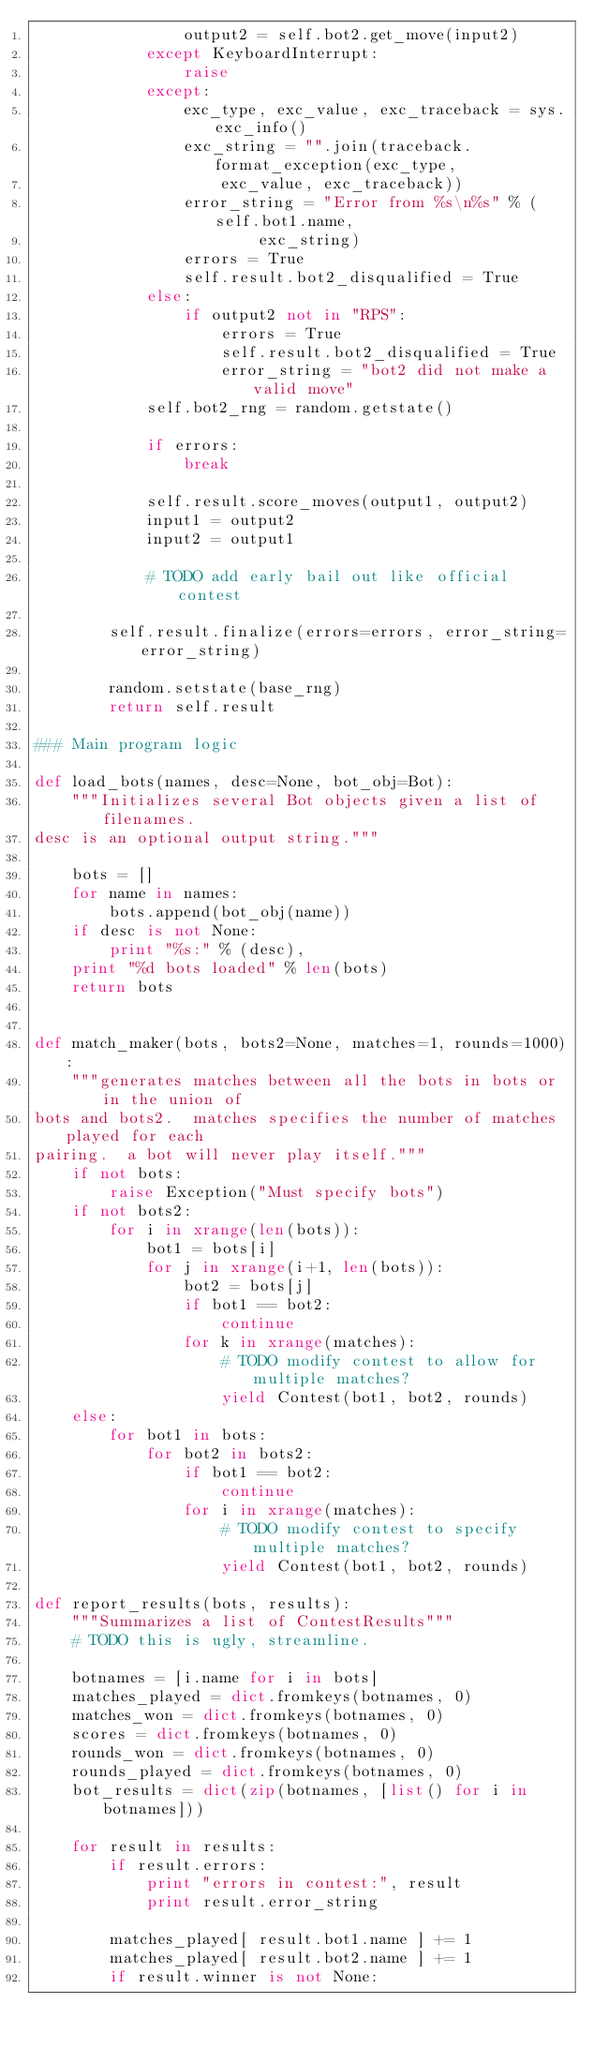<code> <loc_0><loc_0><loc_500><loc_500><_Python_>                output2 = self.bot2.get_move(input2)
            except KeyboardInterrupt:
                raise
            except:
                exc_type, exc_value, exc_traceback = sys.exc_info()
                exc_string = "".join(traceback.format_exception(exc_type,
                    exc_value, exc_traceback))
                error_string = "Error from %s\n%s" % (self.bot1.name,
                        exc_string)
                errors = True
                self.result.bot2_disqualified = True
            else:
                if output2 not in "RPS":
                    errors = True
                    self.result.bot2_disqualified = True
                    error_string = "bot2 did not make a valid move"
            self.bot2_rng = random.getstate()

            if errors:
                break

            self.result.score_moves(output1, output2)
            input1 = output2
            input2 = output1

            # TODO add early bail out like official contest

        self.result.finalize(errors=errors, error_string=error_string)

        random.setstate(base_rng)
        return self.result

### Main program logic

def load_bots(names, desc=None, bot_obj=Bot):
    """Initializes several Bot objects given a list of filenames.
desc is an optional output string."""

    bots = []
    for name in names:
        bots.append(bot_obj(name))
    if desc is not None:
        print "%s:" % (desc),
    print "%d bots loaded" % len(bots)
    return bots


def match_maker(bots, bots2=None, matches=1, rounds=1000):
    """generates matches between all the bots in bots or in the union of
bots and bots2.  matches specifies the number of matches played for each
pairing.  a bot will never play itself."""
    if not bots:
        raise Exception("Must specify bots")
    if not bots2:
        for i in xrange(len(bots)):
            bot1 = bots[i]
            for j in xrange(i+1, len(bots)):
                bot2 = bots[j]
                if bot1 == bot2:
                    continue
                for k in xrange(matches):
                    # TODO modify contest to allow for multiple matches?
                    yield Contest(bot1, bot2, rounds)
    else:
        for bot1 in bots:
            for bot2 in bots2:
                if bot1 == bot2:
                    continue
                for i in xrange(matches):
                    # TODO modify contest to specify multiple matches?
                    yield Contest(bot1, bot2, rounds)

def report_results(bots, results):
    """Summarizes a list of ContestResults"""
    # TODO this is ugly, streamline.

    botnames = [i.name for i in bots]
    matches_played = dict.fromkeys(botnames, 0)
    matches_won = dict.fromkeys(botnames, 0)
    scores = dict.fromkeys(botnames, 0)
    rounds_won = dict.fromkeys(botnames, 0)
    rounds_played = dict.fromkeys(botnames, 0)
    bot_results = dict(zip(botnames, [list() for i in botnames]))

    for result in results:
        if result.errors:
            print "errors in contest:", result
            print result.error_string

        matches_played[ result.bot1.name ] += 1
        matches_played[ result.bot2.name ] += 1
        if result.winner is not None:</code> 